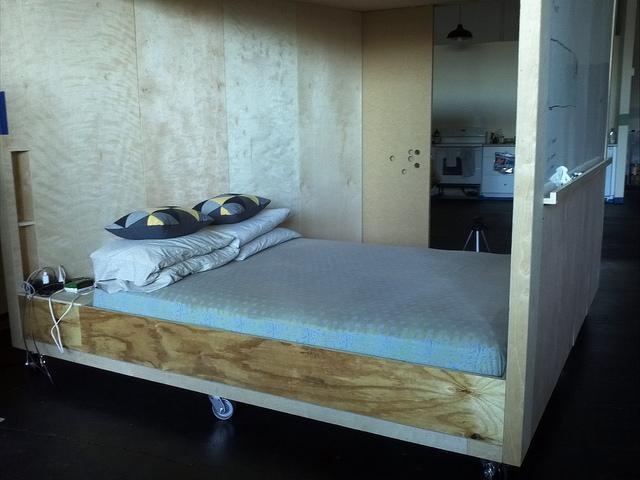How many pillows?
Give a very brief answer. 6. 